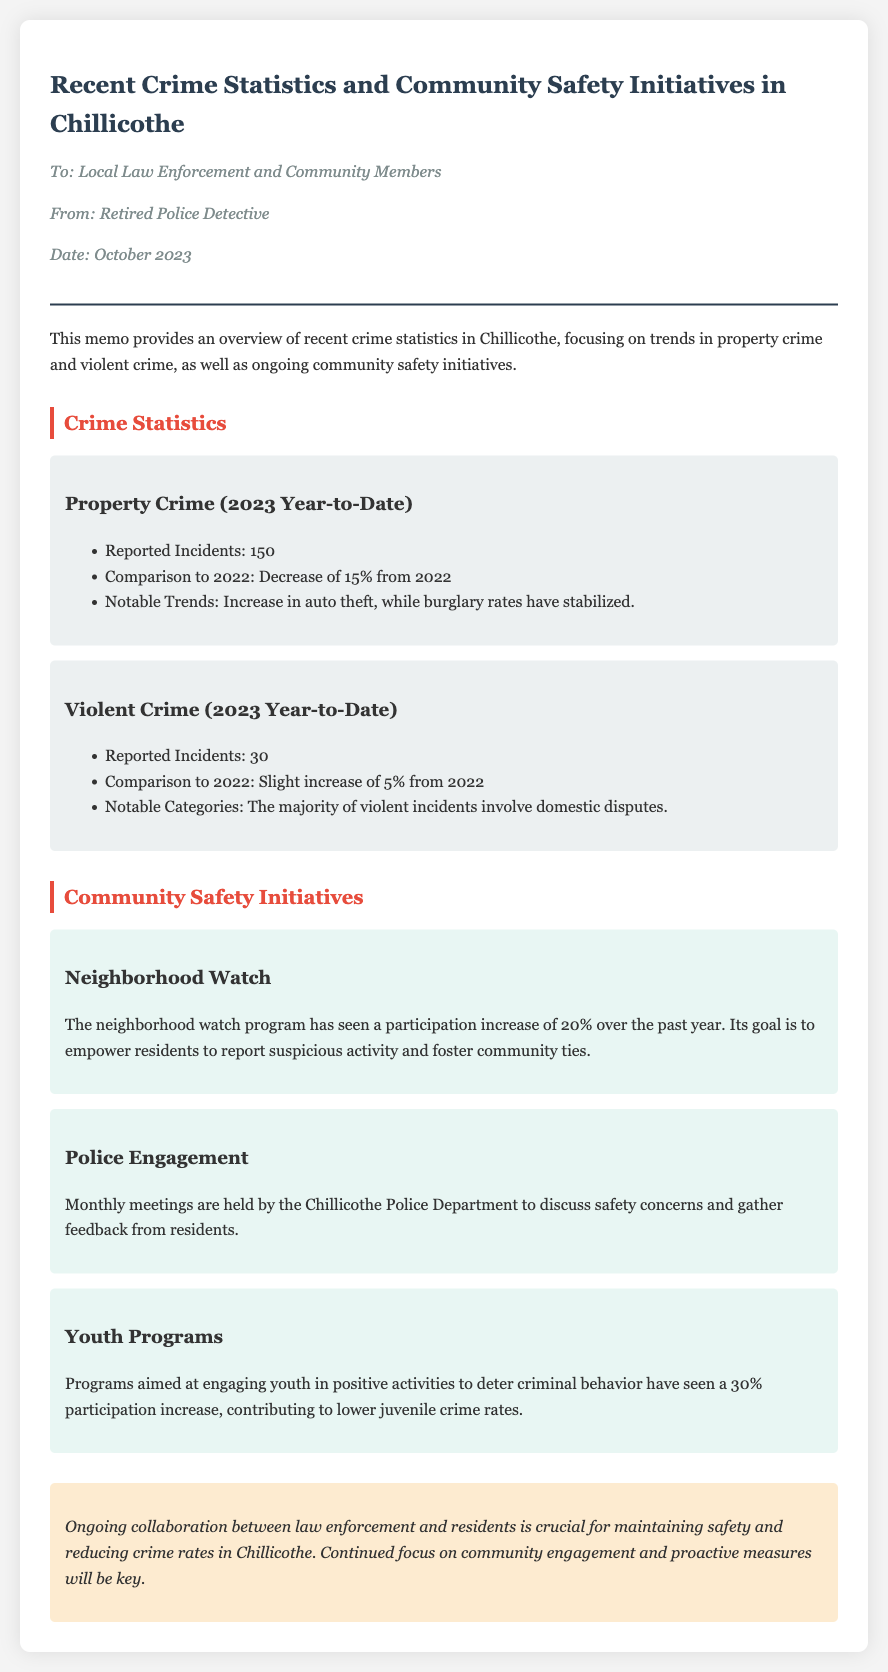What was the reported number of property crime incidents? The document states there were 150 reported incidents of property crime in Chillicothe.
Answer: 150 What is the percentage decrease in property crime compared to 2022? The memo indicates a decrease of 15% from the previous year.
Answer: 15% What trend was noted in auto theft? It was mentioned that there is an increase in auto theft.
Answer: Increase How many reported incidents of violent crime occurred? The memo states there were 30 reported incidents of violent crime in 2023.
Answer: 30 What was the percentage increase in participation in the neighborhood watch program? The document notes a 20% increase in neighborhood watch participation.
Answer: 20% What is the main focus of police engagement meetings? The meetings are focused on discussing safety concerns and gathering resident feedback.
Answer: Safety concerns Which demographic has seen a participation increase of 30% in community programs? The document specifies that youth programs aimed at engaging youth have seen an increase.
Answer: Youth What major category contributes to the majority of violent crime incidents? The memo mentions that the majority involves domestic disputes.
Answer: Domestic disputes What is one of the goals of the neighborhood watch program? The goal is to empower residents to report suspicious activity.
Answer: Empower residents 